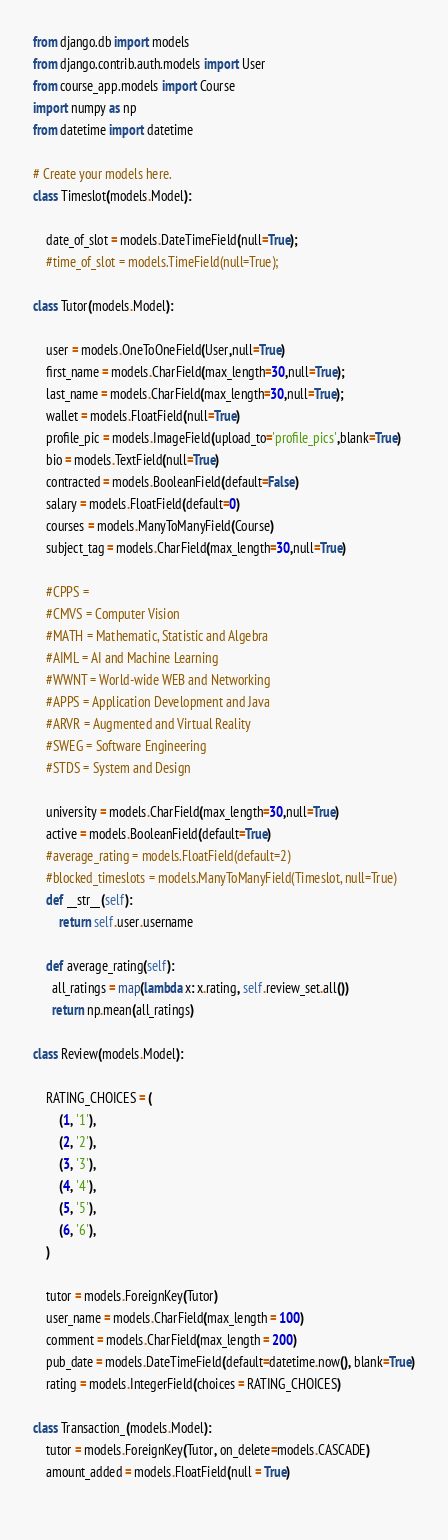<code> <loc_0><loc_0><loc_500><loc_500><_Python_>from django.db import models
from django.contrib.auth.models import User
from course_app.models import Course
import numpy as np
from datetime import datetime

# Create your models here.
class Timeslot(models.Model):
    
    date_of_slot = models.DateTimeField(null=True);
    #time_of_slot = models.TimeField(null=True);

class Tutor(models.Model):

    user = models.OneToOneField(User,null=True)
    first_name = models.CharField(max_length=30,null=True);
    last_name = models.CharField(max_length=30,null=True);
    wallet = models.FloatField(null=True)
    profile_pic = models.ImageField(upload_to='profile_pics',blank=True)
    bio = models.TextField(null=True)
    contracted = models.BooleanField(default=False)
    salary = models.FloatField(default=0)
    courses = models.ManyToManyField(Course)
    subject_tag = models.CharField(max_length=30,null=True)
    
    #CPPS = 
    #CMVS = Computer Vision
    #MATH = Mathematic, Statistic and Algebra
    #AIML = AI and Machine Learning
    #WWNT = World-wide WEB and Networking
    #APPS = Application Development and Java
    #ARVR = Augmented and Virtual Reality
    #SWEG = Software Engineering
    #STDS = System and Design

    university = models.CharField(max_length=30,null=True)
    active = models.BooleanField(default=True)
    #average_rating = models.FloatField(default=2)
    #blocked_timeslots = models.ManyToManyField(Timeslot, null=True)
    def __str__(self):
        return self.user.username
        
    def average_rating(self):
      all_ratings = map(lambda x: x.rating, self.review_set.all())
      return np.mean(all_ratings)
        
class Review(models.Model):
    
    RATING_CHOICES = (
        (1, '1'),
        (2, '2'),
        (3, '3'),
        (4, '4'),
        (5, '5'),
        (6, '6'),
    )
    
    tutor = models.ForeignKey(Tutor)
    user_name = models.CharField(max_length = 100)
    comment = models.CharField(max_length = 200)
    pub_date = models.DateTimeField(default=datetime.now(), blank=True)
    rating = models.IntegerField(choices = RATING_CHOICES)
    
class Transaction_(models.Model):
    tutor = models.ForeignKey(Tutor, on_delete=models.CASCADE)
    amount_added = models.FloatField(null = True)
    </code> 